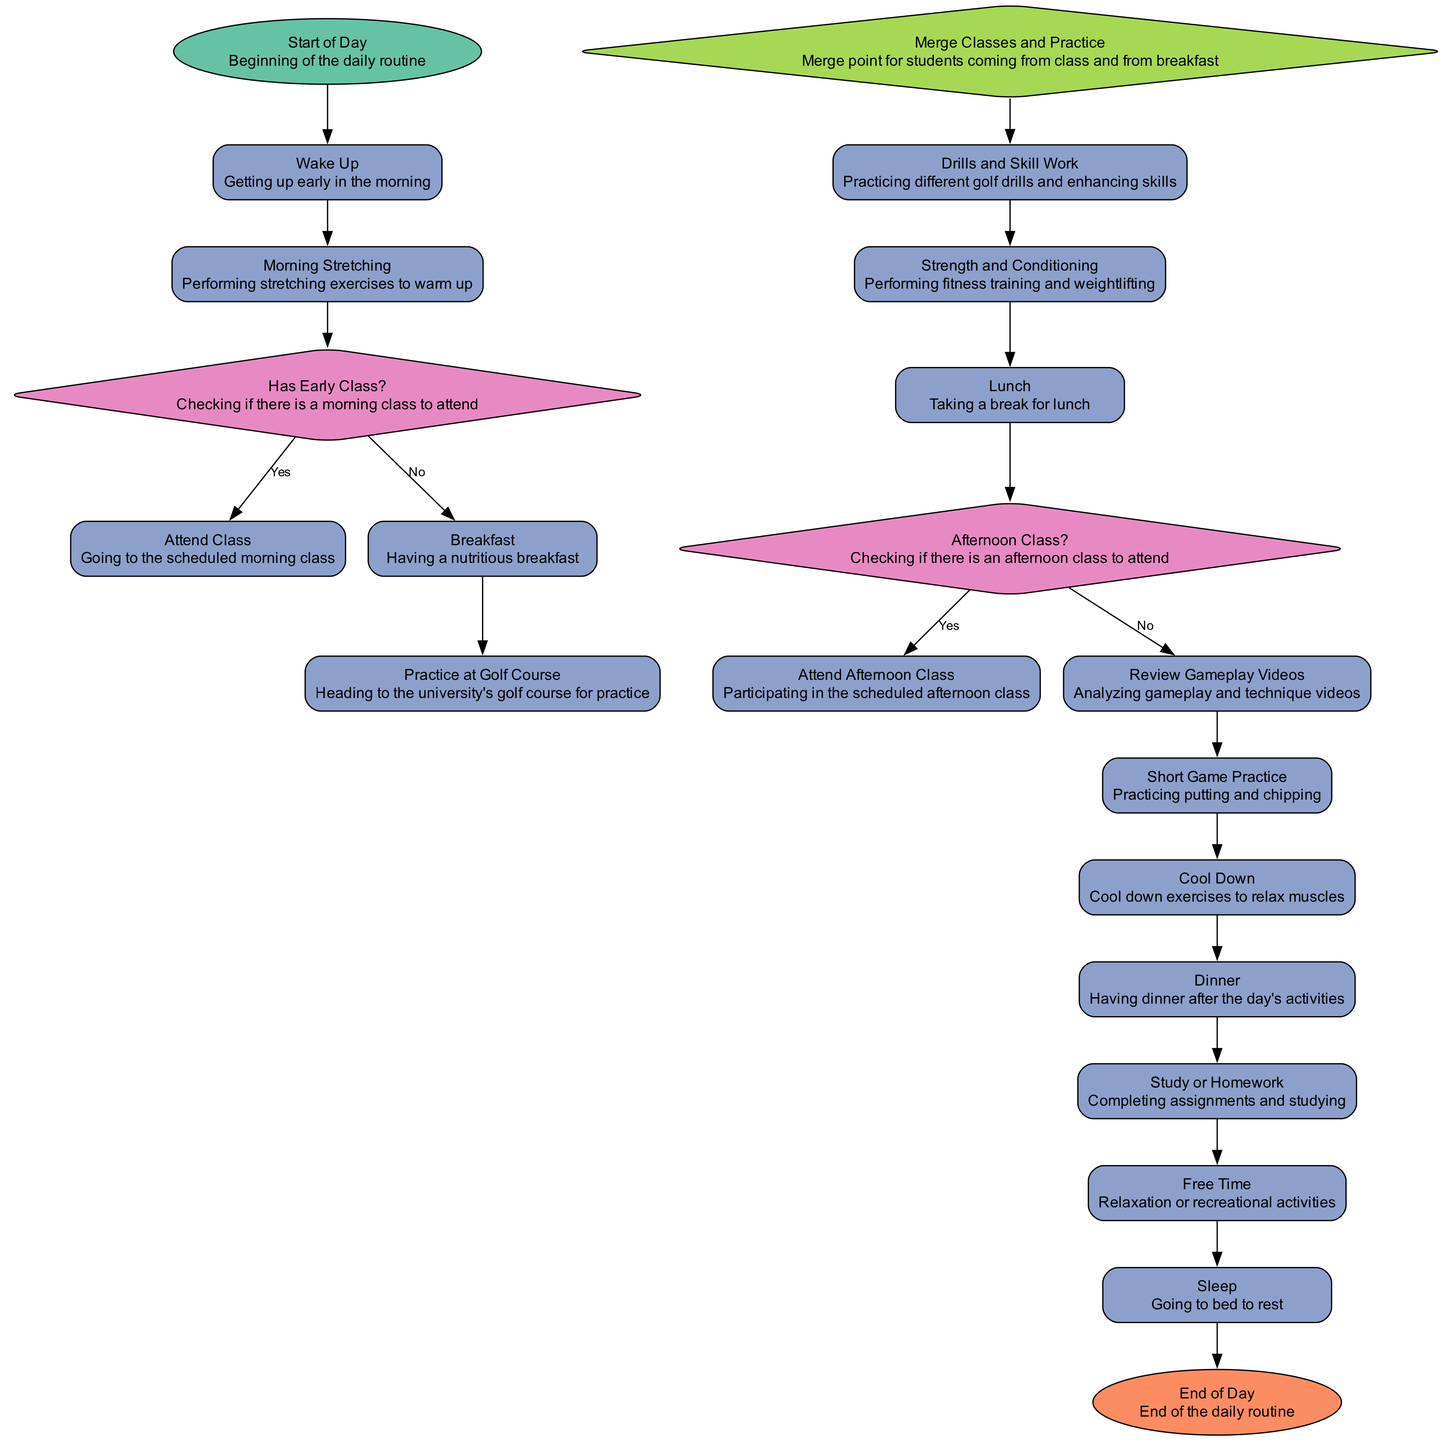What is the first action in the daily routine? The first action is "Wake Up," which follows the "Start of Day" node. It is directly linked to the starting point of the daily routine.
Answer: Wake Up How many decision nodes are in the diagram? The diagram contains two decision nodes: "Has Early Class?" and "Afternoon Class?" Counting these gives a total of two decision nodes.
Answer: 2 What action comes after "Strength and Conditioning"? The action that follows "Strength and Conditioning" is "Lunch." After completing fitness training, the next step is to take a break for lunch.
Answer: Lunch Which action is taken if there is no afternoon class? If there is no afternoon class, the golfer will proceed to "Review Gameplay Videos." This is the designated action to follow in the absence of an afternoon class.
Answer: Review Gameplay Videos How does a golfer proceed if they have an early class? If the golfer has an early class, they will first go to "Attend Class," which is the action taken in that case. This occurs after "Morning Stretching" and before practicing at the golf course.
Answer: Attend Class What action is performed before "Cool Down"? The action performed before "Cool Down" is "Short Game Practice." The golfer practices putting and chipping before transitioning to cool down exercises.
Answer: Short Game Practice What is the final action before going to sleep? The last action before going to sleep is "Free Time." After completing studies, the golfer has free time before the end of the day.
Answer: Free Time What is the last node in the daily routine? The last node is labeled "End of Day." This node signifies the conclusion of the daily routine for the golfer.
Answer: End of Day What is the merge point in the daily routine? The merge point is "Merge Classes and Practice," which combines the paths of students coming from either class or breakfast, indicating a common flow into practice activities.
Answer: Merge Classes and Practice 